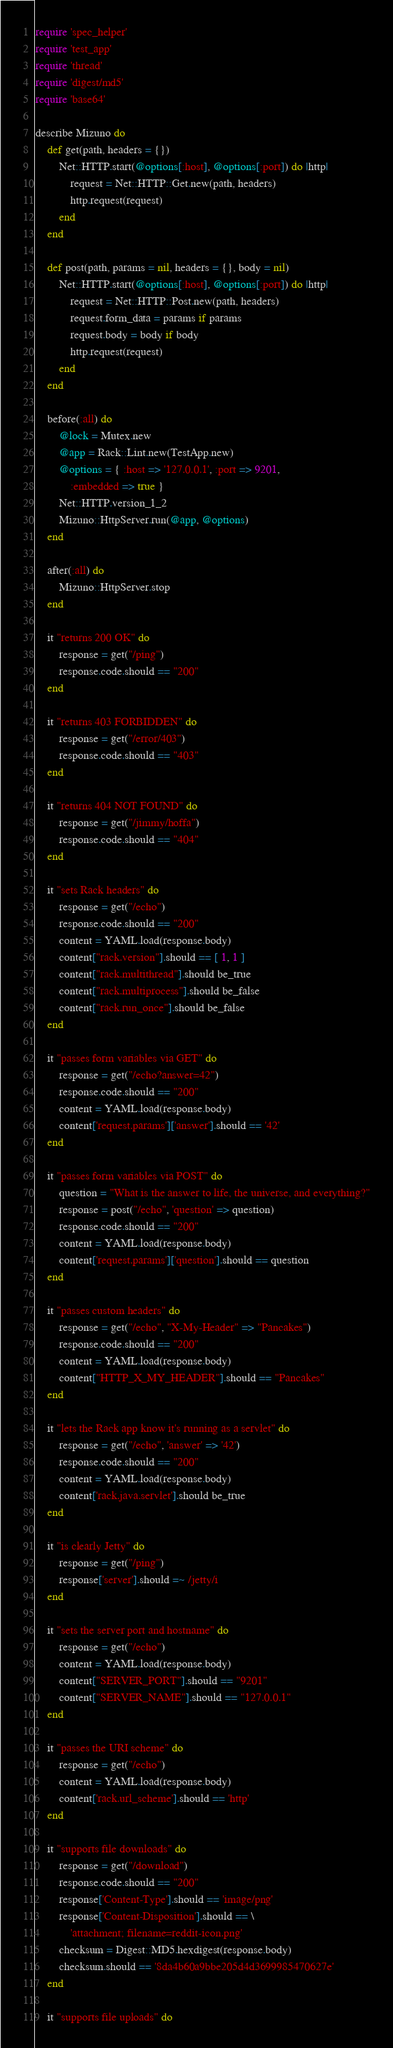Convert code to text. <code><loc_0><loc_0><loc_500><loc_500><_Ruby_>require 'spec_helper'
require 'test_app'
require 'thread'
require 'digest/md5'
require 'base64'

describe Mizuno do
    def get(path, headers = {})
        Net::HTTP.start(@options[:host], @options[:port]) do |http|
            request = Net::HTTP::Get.new(path, headers)
            http.request(request)
        end
    end

    def post(path, params = nil, headers = {}, body = nil)
        Net::HTTP.start(@options[:host], @options[:port]) do |http|
            request = Net::HTTP::Post.new(path, headers)
            request.form_data = params if params
            request.body = body if body
            http.request(request)
        end
    end

    before(:all) do
        @lock = Mutex.new
        @app = Rack::Lint.new(TestApp.new)
        @options = { :host => '127.0.0.1', :port => 9201, 
            :embedded => true }
        Net::HTTP.version_1_2
        Mizuno::HttpServer.run(@app, @options)
    end

    after(:all) do
        Mizuno::HttpServer.stop
    end

    it "returns 200 OK" do
        response = get("/ping")
        response.code.should == "200"
    end

    it "returns 403 FORBIDDEN" do
        response = get("/error/403")
        response.code.should == "403"
    end

    it "returns 404 NOT FOUND" do
        response = get("/jimmy/hoffa")
        response.code.should == "404"
    end

    it "sets Rack headers" do
        response = get("/echo")
        response.code.should == "200"
        content = YAML.load(response.body)
        content["rack.version"].should == [ 1, 1 ]
        content["rack.multithread"].should be_true
        content["rack.multiprocess"].should be_false
        content["rack.run_once"].should be_false
    end

    it "passes form variables via GET" do
        response = get("/echo?answer=42")
        response.code.should == "200"
        content = YAML.load(response.body)
        content['request.params']['answer'].should == '42'
    end

    it "passes form variables via POST" do
        question = "What is the answer to life, the universe, and everything?"
        response = post("/echo", 'question' => question)
        response.code.should == "200"
        content = YAML.load(response.body)
        content['request.params']['question'].should == question
    end

    it "passes custom headers" do
        response = get("/echo", "X-My-Header" => "Pancakes")
        response.code.should == "200"
        content = YAML.load(response.body)
        content["HTTP_X_MY_HEADER"].should == "Pancakes"
    end

    it "lets the Rack app know it's running as a servlet" do
        response = get("/echo", 'answer' => '42')
        response.code.should == "200"
        content = YAML.load(response.body)
        content['rack.java.servlet'].should be_true
    end

    it "is clearly Jetty" do
        response = get("/ping")
        response['server'].should =~ /jetty/i
    end

    it "sets the server port and hostname" do
        response = get("/echo")
        content = YAML.load(response.body)
        content["SERVER_PORT"].should == "9201"
        content["SERVER_NAME"].should == "127.0.0.1"
    end

    it "passes the URI scheme" do
        response = get("/echo")
        content = YAML.load(response.body)
        content['rack.url_scheme'].should == 'http'
    end

    it "supports file downloads" do
        response = get("/download")
        response.code.should == "200"
        response['Content-Type'].should == 'image/png'
        response['Content-Disposition'].should == \
            'attachment; filename=reddit-icon.png'
        checksum = Digest::MD5.hexdigest(response.body)
        checksum.should == '8da4b60a9bbe205d4d3699985470627e'
    end

    it "supports file uploads" do</code> 